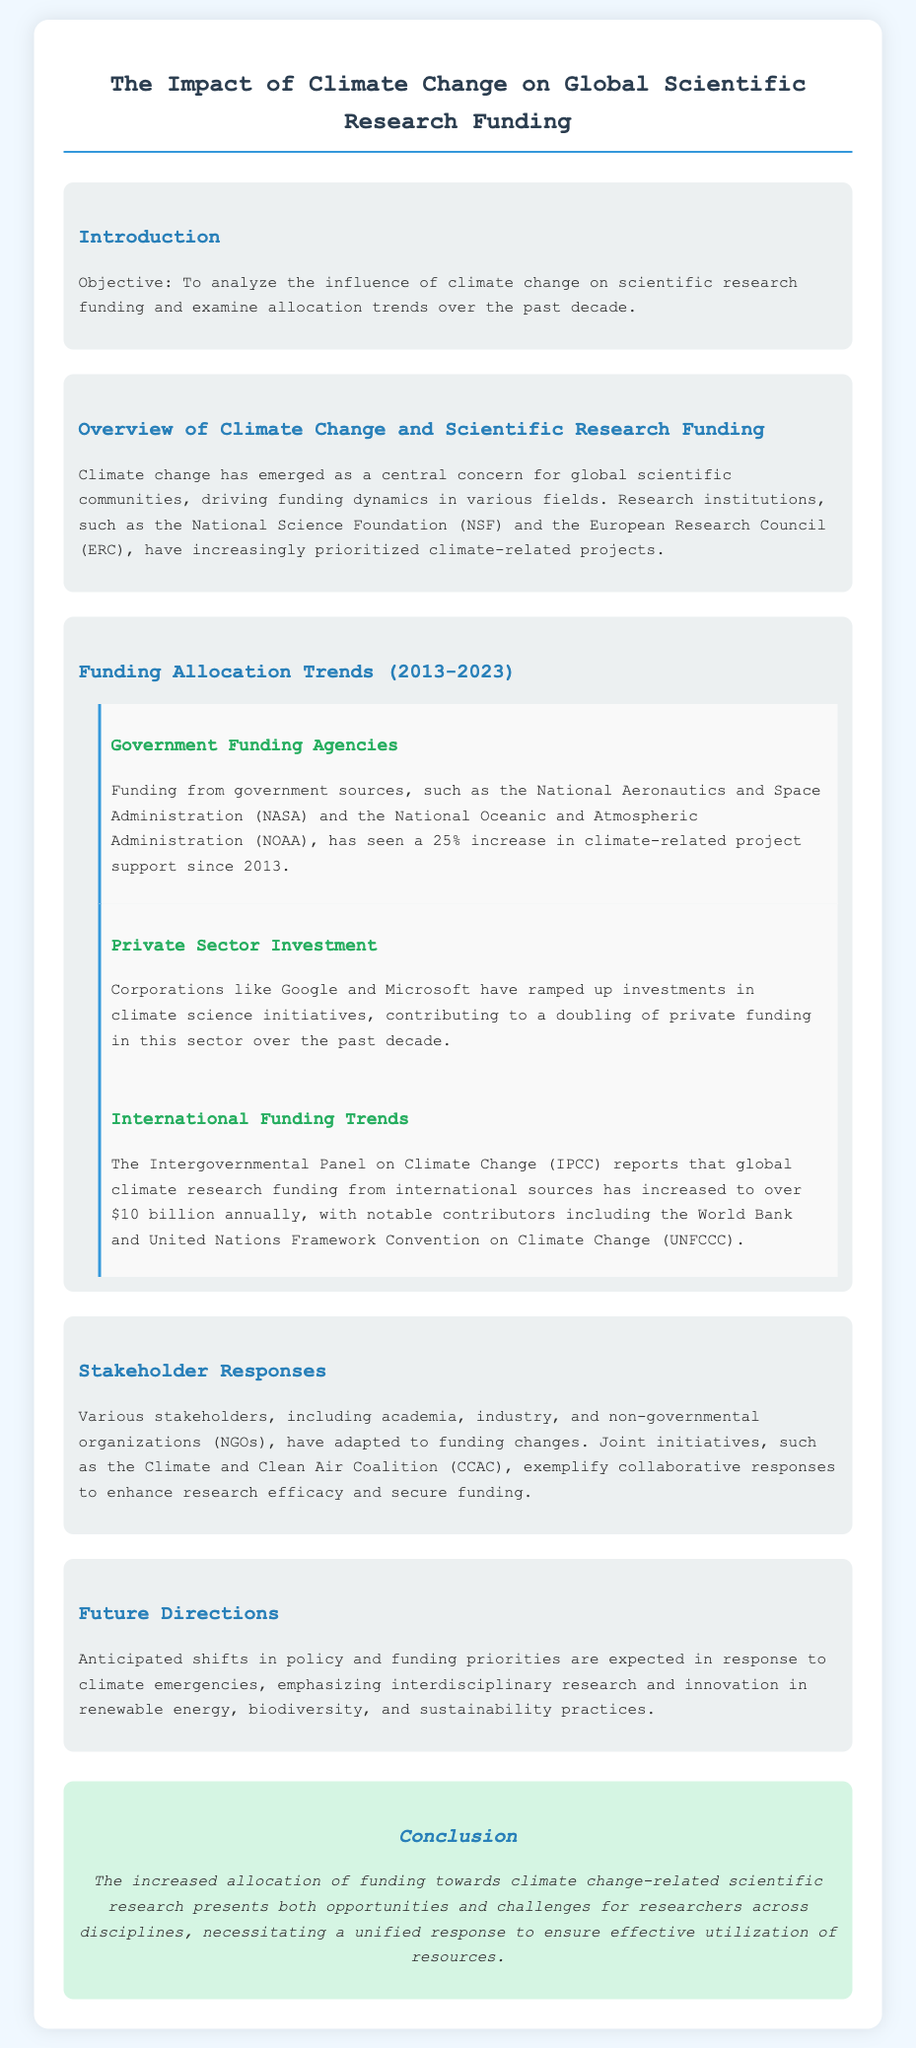What is the objective of the document? The objective of the document is stated in the introduction section, which aims to analyze the influence of climate change on scientific research funding.
Answer: Analyze the influence of climate change on scientific research funding By what percentage has government funding for climate-related projects increased since 2013? The document mentions the specific increase in government funding for climate-related projects, which is quantified as a percentage.
Answer: 25% Which organization reports global climate research funding has reached over $10 billion annually? The document attributes the report of over $10 billion in global climate research funding to a specific organization, which is listed in the document.
Answer: Intergovernmental Panel on Climate Change (IPCC) What has happened to private sector investment in climate science initiatives over the past decade? The document describes the trend in private sector investment for climate science initiatives and notes a particular outcome of that trend.
Answer: Doubled Name one example of a joint initiative responding to funding changes. The document provides an example of a collaborative initiative among various stakeholders addressing changes in funding.
Answer: Climate and Clean Air Coalition (CCAC) What is emphasized in anticipated future policy shifts regarding research? The document highlights a specific focus of anticipated shifts in policy and funding priorities connected to climate emergencies.
Answer: Interdisciplinary research What has been a notable contributor to international climate research funding? The document lists contributors to international climate research funding, pointing out a notable organization.
Answer: World Bank In what year range does the funding allocation trends section analyze trends? The document specifies the range of years it focuses on regarding funding allocation trends.
Answer: 2013-2023 